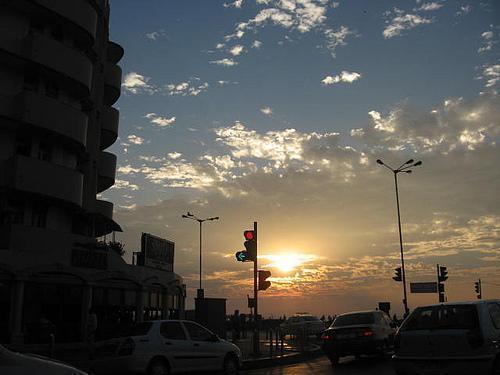How many lightbulbs does it take to fill each lamp post?
Give a very brief answer. 4. How many cars are there?
Give a very brief answer. 3. 